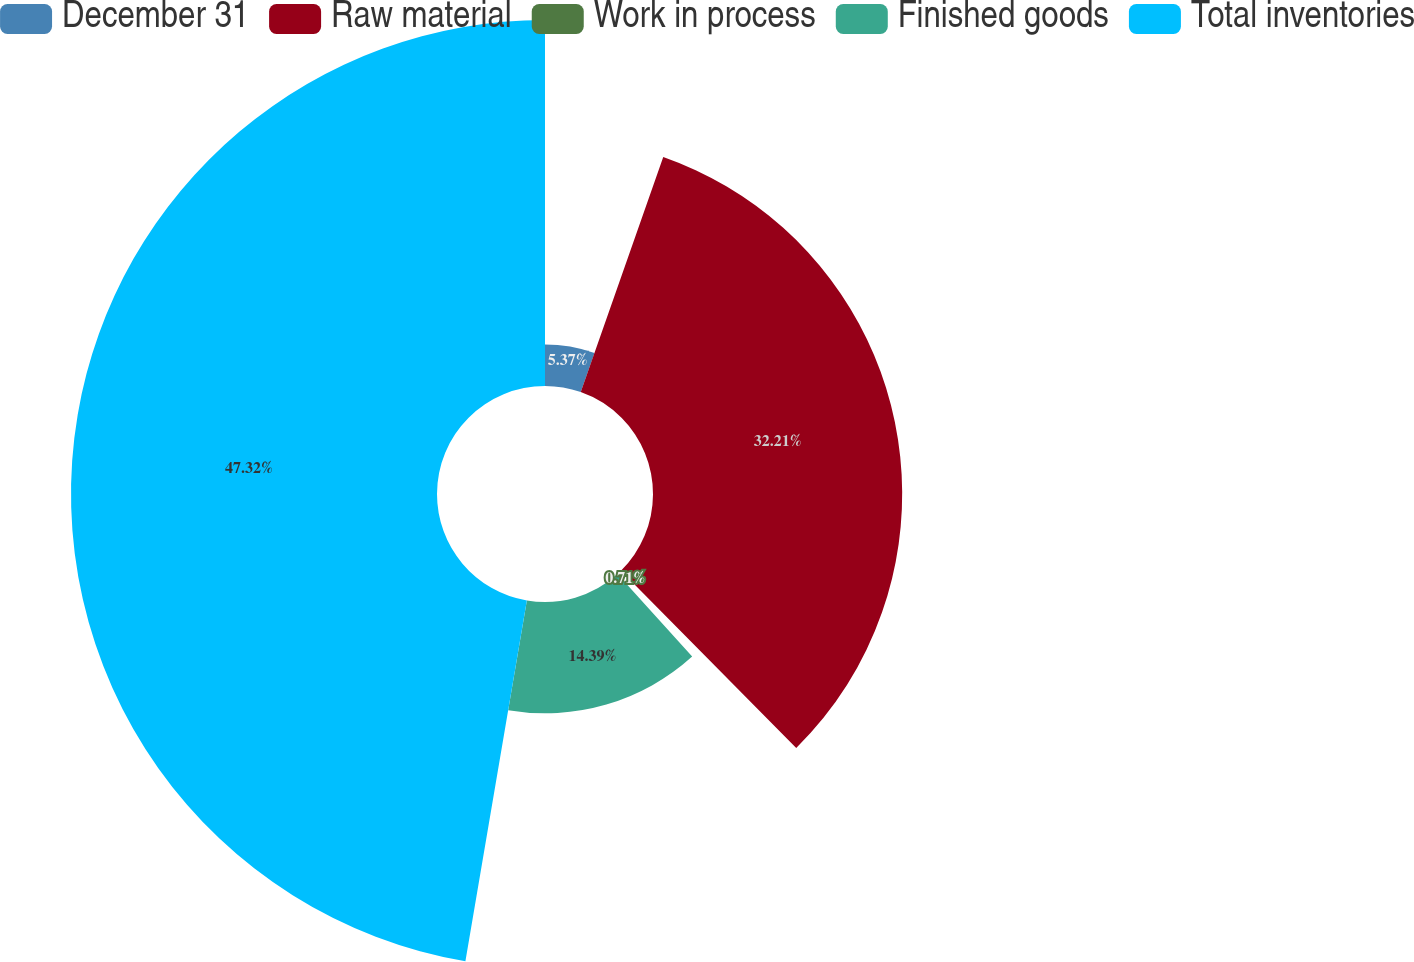<chart> <loc_0><loc_0><loc_500><loc_500><pie_chart><fcel>December 31<fcel>Raw material<fcel>Work in process<fcel>Finished goods<fcel>Total inventories<nl><fcel>5.37%<fcel>32.21%<fcel>0.71%<fcel>14.39%<fcel>47.31%<nl></chart> 